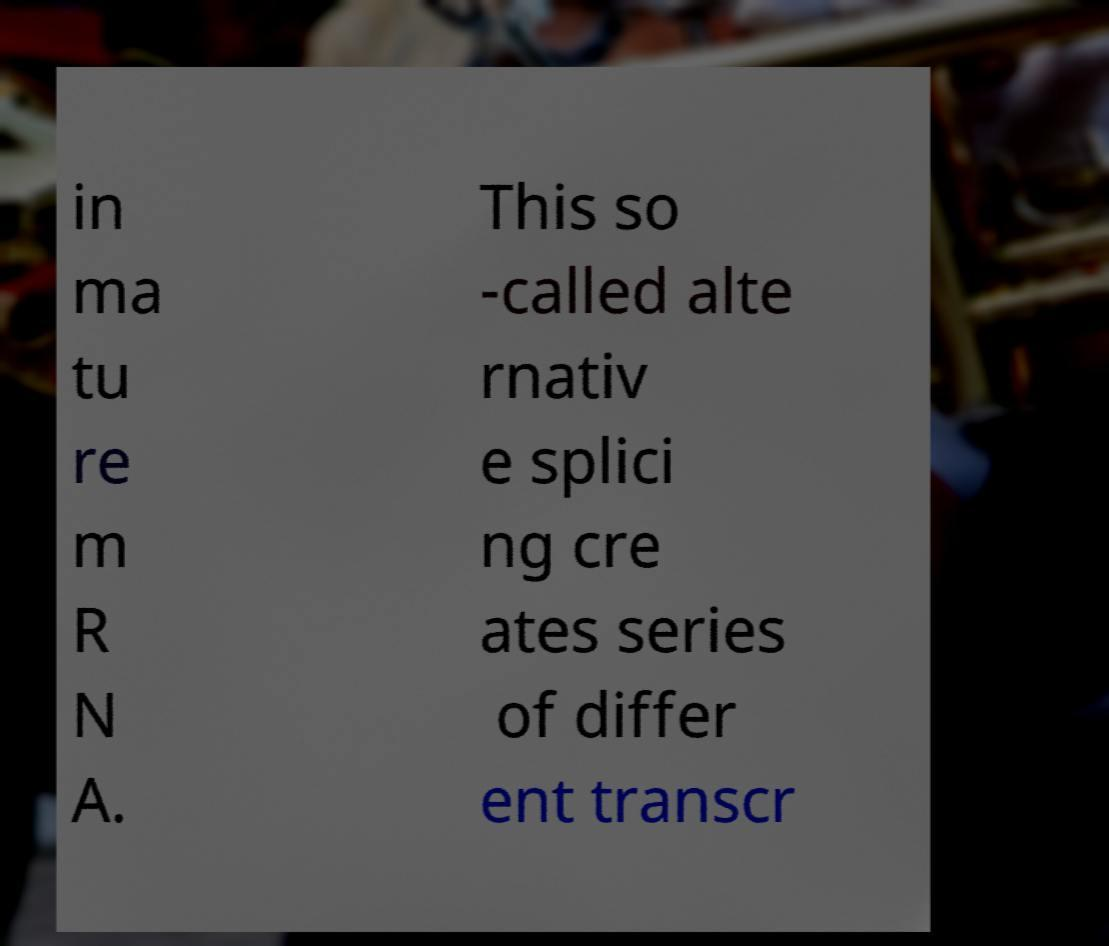Could you extract and type out the text from this image? in ma tu re m R N A. This so -called alte rnativ e splici ng cre ates series of differ ent transcr 